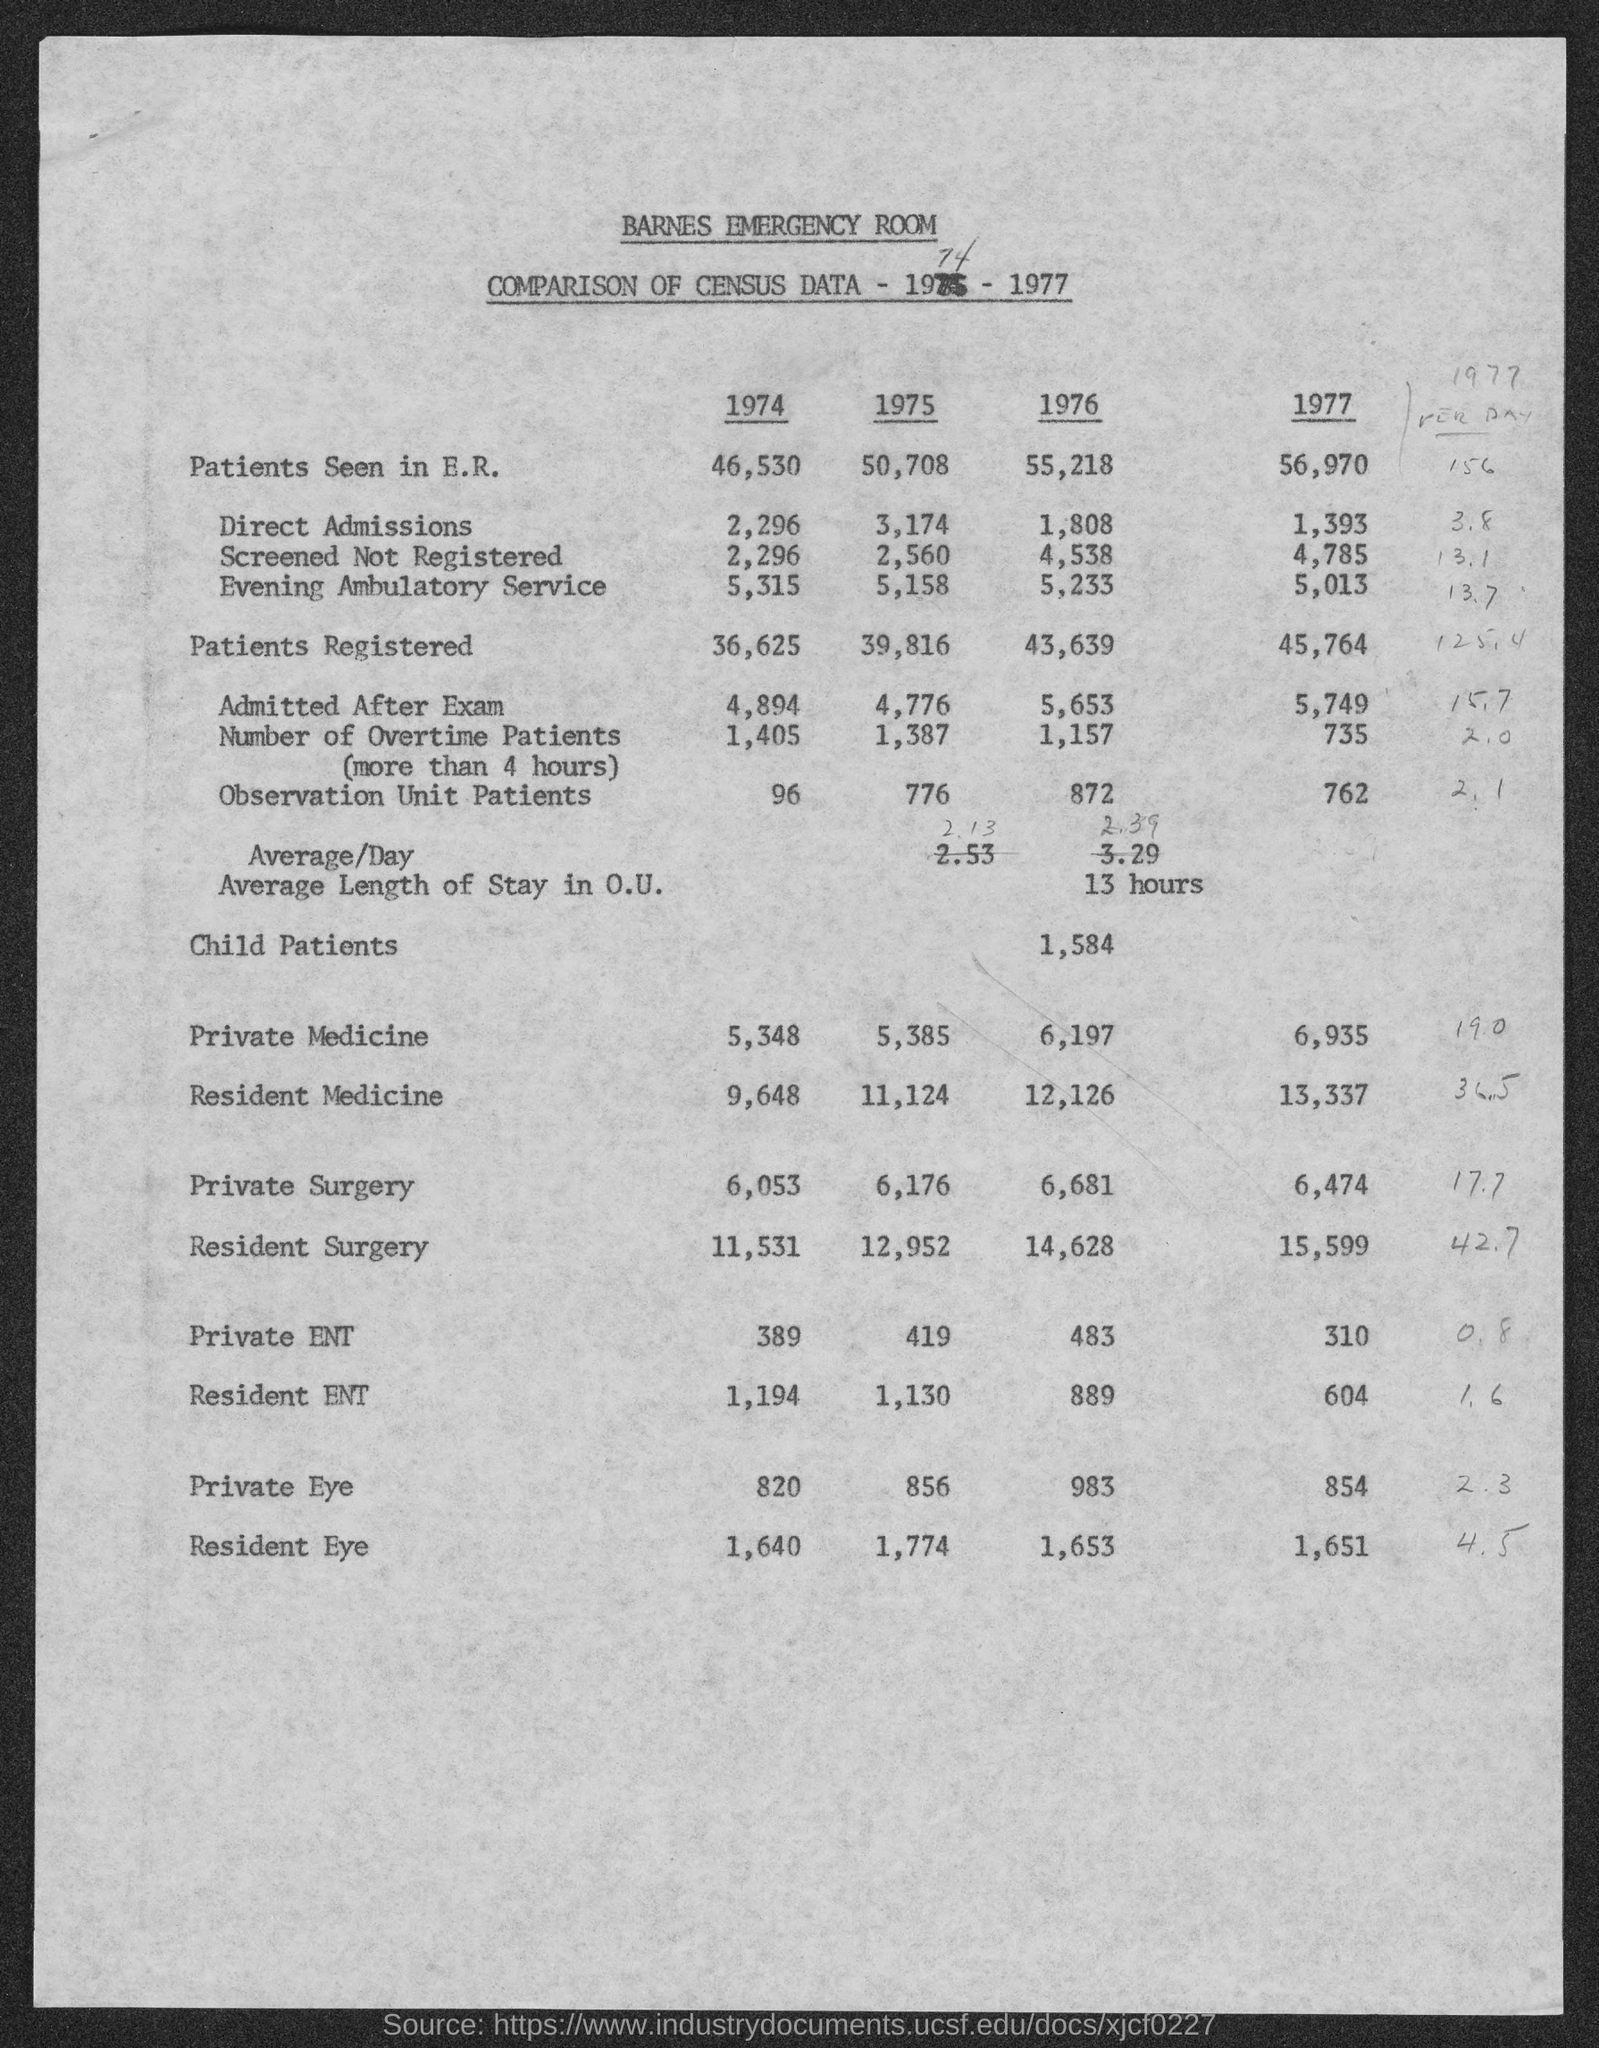What is the first title in the document?
Provide a short and direct response. Barnes Emergency Room. What is the number of overtime patients in 1974?
Offer a terse response. 1,405. What is the number of direct admissions 1975?
Make the answer very short. 3,174. The number of patients registered is higher in which year?
Offer a terse response. 1977. The number of direct admissions is lower in which year?
Your answer should be very brief. 1977. The number of observation unit patients is higher in which year?
Your answer should be compact. 1976. What is the number of child patients in the year 1976?
Ensure brevity in your answer.  1,584. 